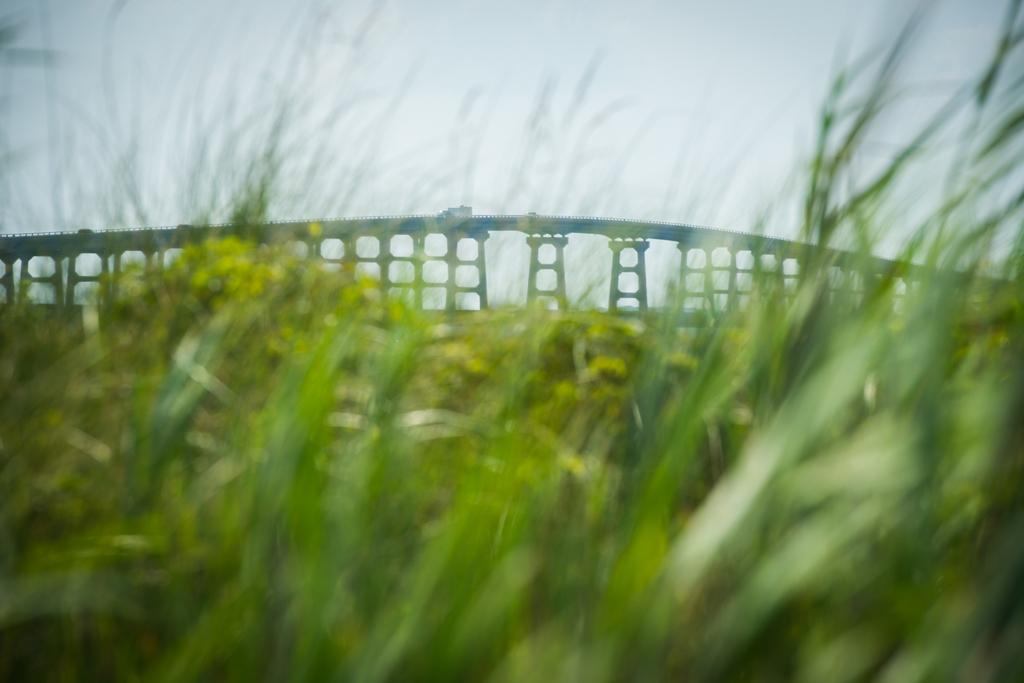What type of vegetation is present in the image? There is grass in the image. What type of structure can be seen in the background of the image? There is a bridge with pillars in the background of the image. What part of the natural environment is visible in the image? The sky is visible in the background of the image. What type of stem can be seen growing from the grass in the image? There is no stem growing from the grass in the image; it is simply a field of grass. 